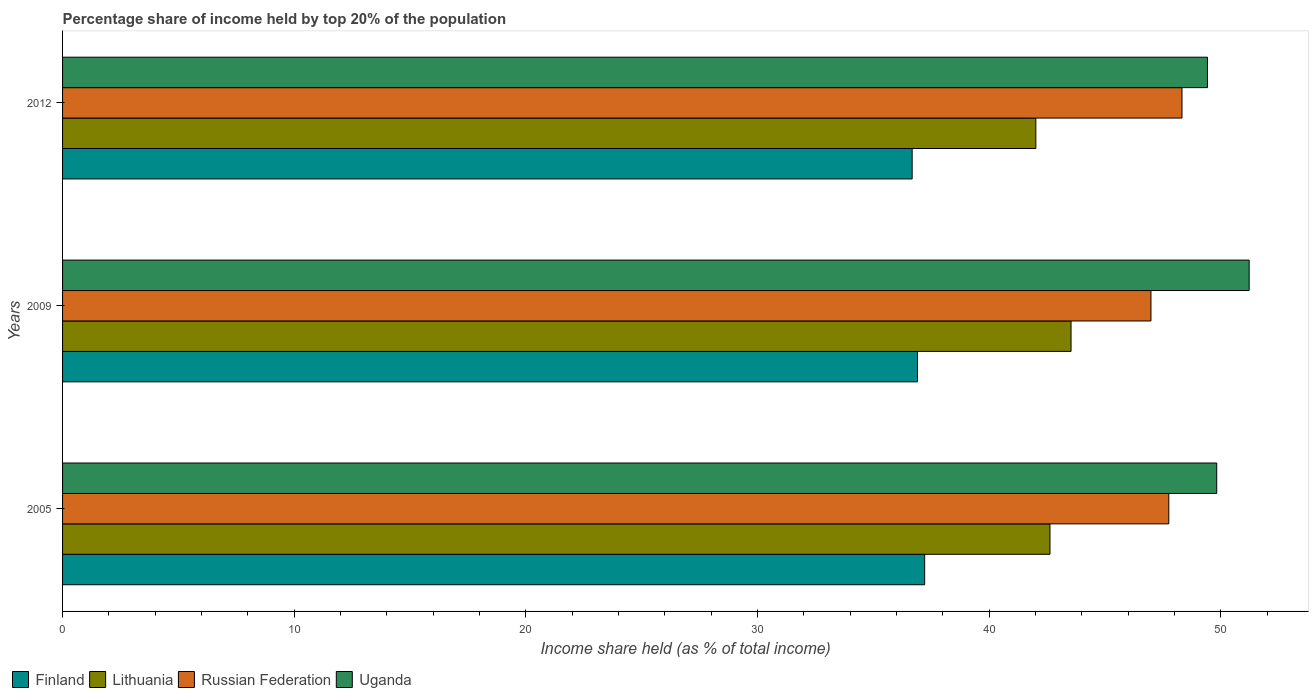Are the number of bars per tick equal to the number of legend labels?
Make the answer very short. Yes. Are the number of bars on each tick of the Y-axis equal?
Your answer should be very brief. Yes. How many bars are there on the 2nd tick from the top?
Offer a terse response. 4. How many bars are there on the 2nd tick from the bottom?
Your answer should be compact. 4. What is the label of the 2nd group of bars from the top?
Make the answer very short. 2009. In how many cases, is the number of bars for a given year not equal to the number of legend labels?
Provide a short and direct response. 0. What is the percentage share of income held by top 20% of the population in Uganda in 2009?
Provide a short and direct response. 51.23. Across all years, what is the maximum percentage share of income held by top 20% of the population in Russian Federation?
Make the answer very short. 48.33. Across all years, what is the minimum percentage share of income held by top 20% of the population in Lithuania?
Make the answer very short. 42.02. In which year was the percentage share of income held by top 20% of the population in Uganda minimum?
Keep it short and to the point. 2012. What is the total percentage share of income held by top 20% of the population in Russian Federation in the graph?
Offer a terse response. 143.08. What is the difference between the percentage share of income held by top 20% of the population in Lithuania in 2009 and that in 2012?
Make the answer very short. 1.52. What is the difference between the percentage share of income held by top 20% of the population in Uganda in 2005 and the percentage share of income held by top 20% of the population in Finland in 2012?
Your answer should be very brief. 13.15. What is the average percentage share of income held by top 20% of the population in Finland per year?
Offer a very short reply. 36.94. In the year 2012, what is the difference between the percentage share of income held by top 20% of the population in Uganda and percentage share of income held by top 20% of the population in Finland?
Provide a succinct answer. 12.75. In how many years, is the percentage share of income held by top 20% of the population in Uganda greater than 4 %?
Your answer should be compact. 3. What is the ratio of the percentage share of income held by top 20% of the population in Finland in 2005 to that in 2012?
Ensure brevity in your answer.  1.01. Is the percentage share of income held by top 20% of the population in Lithuania in 2005 less than that in 2012?
Your answer should be very brief. No. What is the difference between the highest and the second highest percentage share of income held by top 20% of the population in Russian Federation?
Offer a terse response. 0.57. What is the difference between the highest and the lowest percentage share of income held by top 20% of the population in Russian Federation?
Ensure brevity in your answer.  1.34. In how many years, is the percentage share of income held by top 20% of the population in Uganda greater than the average percentage share of income held by top 20% of the population in Uganda taken over all years?
Provide a succinct answer. 1. Is the sum of the percentage share of income held by top 20% of the population in Uganda in 2005 and 2009 greater than the maximum percentage share of income held by top 20% of the population in Lithuania across all years?
Your answer should be compact. Yes. Is it the case that in every year, the sum of the percentage share of income held by top 20% of the population in Finland and percentage share of income held by top 20% of the population in Lithuania is greater than the sum of percentage share of income held by top 20% of the population in Uganda and percentage share of income held by top 20% of the population in Russian Federation?
Your answer should be very brief. Yes. What does the 3rd bar from the top in 2009 represents?
Provide a short and direct response. Lithuania. What does the 1st bar from the bottom in 2012 represents?
Offer a very short reply. Finland. How many bars are there?
Provide a succinct answer. 12. Are all the bars in the graph horizontal?
Give a very brief answer. Yes. How many years are there in the graph?
Keep it short and to the point. 3. What is the difference between two consecutive major ticks on the X-axis?
Your answer should be compact. 10. Does the graph contain grids?
Provide a short and direct response. No. Where does the legend appear in the graph?
Offer a very short reply. Bottom left. How are the legend labels stacked?
Provide a succinct answer. Horizontal. What is the title of the graph?
Your answer should be compact. Percentage share of income held by top 20% of the population. Does "Kiribati" appear as one of the legend labels in the graph?
Ensure brevity in your answer.  No. What is the label or title of the X-axis?
Ensure brevity in your answer.  Income share held (as % of total income). What is the label or title of the Y-axis?
Offer a terse response. Years. What is the Income share held (as % of total income) in Finland in 2005?
Offer a very short reply. 37.22. What is the Income share held (as % of total income) of Lithuania in 2005?
Offer a terse response. 42.63. What is the Income share held (as % of total income) in Russian Federation in 2005?
Ensure brevity in your answer.  47.76. What is the Income share held (as % of total income) of Uganda in 2005?
Your answer should be very brief. 49.83. What is the Income share held (as % of total income) in Finland in 2009?
Ensure brevity in your answer.  36.91. What is the Income share held (as % of total income) in Lithuania in 2009?
Provide a short and direct response. 43.54. What is the Income share held (as % of total income) in Russian Federation in 2009?
Your answer should be compact. 46.99. What is the Income share held (as % of total income) in Uganda in 2009?
Keep it short and to the point. 51.23. What is the Income share held (as % of total income) in Finland in 2012?
Provide a short and direct response. 36.68. What is the Income share held (as % of total income) of Lithuania in 2012?
Ensure brevity in your answer.  42.02. What is the Income share held (as % of total income) in Russian Federation in 2012?
Provide a short and direct response. 48.33. What is the Income share held (as % of total income) in Uganda in 2012?
Your answer should be very brief. 49.43. Across all years, what is the maximum Income share held (as % of total income) in Finland?
Offer a very short reply. 37.22. Across all years, what is the maximum Income share held (as % of total income) of Lithuania?
Offer a very short reply. 43.54. Across all years, what is the maximum Income share held (as % of total income) in Russian Federation?
Your answer should be compact. 48.33. Across all years, what is the maximum Income share held (as % of total income) in Uganda?
Your answer should be compact. 51.23. Across all years, what is the minimum Income share held (as % of total income) of Finland?
Your answer should be very brief. 36.68. Across all years, what is the minimum Income share held (as % of total income) of Lithuania?
Ensure brevity in your answer.  42.02. Across all years, what is the minimum Income share held (as % of total income) in Russian Federation?
Your answer should be very brief. 46.99. Across all years, what is the minimum Income share held (as % of total income) in Uganda?
Provide a short and direct response. 49.43. What is the total Income share held (as % of total income) of Finland in the graph?
Your response must be concise. 110.81. What is the total Income share held (as % of total income) in Lithuania in the graph?
Offer a terse response. 128.19. What is the total Income share held (as % of total income) in Russian Federation in the graph?
Provide a succinct answer. 143.08. What is the total Income share held (as % of total income) of Uganda in the graph?
Give a very brief answer. 150.49. What is the difference between the Income share held (as % of total income) in Finland in 2005 and that in 2009?
Provide a succinct answer. 0.31. What is the difference between the Income share held (as % of total income) of Lithuania in 2005 and that in 2009?
Offer a terse response. -0.91. What is the difference between the Income share held (as % of total income) of Russian Federation in 2005 and that in 2009?
Keep it short and to the point. 0.77. What is the difference between the Income share held (as % of total income) in Finland in 2005 and that in 2012?
Give a very brief answer. 0.54. What is the difference between the Income share held (as % of total income) in Lithuania in 2005 and that in 2012?
Your response must be concise. 0.61. What is the difference between the Income share held (as % of total income) of Russian Federation in 2005 and that in 2012?
Make the answer very short. -0.57. What is the difference between the Income share held (as % of total income) of Finland in 2009 and that in 2012?
Your answer should be compact. 0.23. What is the difference between the Income share held (as % of total income) in Lithuania in 2009 and that in 2012?
Your response must be concise. 1.52. What is the difference between the Income share held (as % of total income) of Russian Federation in 2009 and that in 2012?
Make the answer very short. -1.34. What is the difference between the Income share held (as % of total income) in Finland in 2005 and the Income share held (as % of total income) in Lithuania in 2009?
Make the answer very short. -6.32. What is the difference between the Income share held (as % of total income) of Finland in 2005 and the Income share held (as % of total income) of Russian Federation in 2009?
Keep it short and to the point. -9.77. What is the difference between the Income share held (as % of total income) in Finland in 2005 and the Income share held (as % of total income) in Uganda in 2009?
Provide a succinct answer. -14.01. What is the difference between the Income share held (as % of total income) in Lithuania in 2005 and the Income share held (as % of total income) in Russian Federation in 2009?
Keep it short and to the point. -4.36. What is the difference between the Income share held (as % of total income) of Russian Federation in 2005 and the Income share held (as % of total income) of Uganda in 2009?
Your answer should be compact. -3.47. What is the difference between the Income share held (as % of total income) in Finland in 2005 and the Income share held (as % of total income) in Lithuania in 2012?
Keep it short and to the point. -4.8. What is the difference between the Income share held (as % of total income) of Finland in 2005 and the Income share held (as % of total income) of Russian Federation in 2012?
Offer a terse response. -11.11. What is the difference between the Income share held (as % of total income) in Finland in 2005 and the Income share held (as % of total income) in Uganda in 2012?
Provide a short and direct response. -12.21. What is the difference between the Income share held (as % of total income) in Russian Federation in 2005 and the Income share held (as % of total income) in Uganda in 2012?
Your answer should be compact. -1.67. What is the difference between the Income share held (as % of total income) in Finland in 2009 and the Income share held (as % of total income) in Lithuania in 2012?
Your response must be concise. -5.11. What is the difference between the Income share held (as % of total income) in Finland in 2009 and the Income share held (as % of total income) in Russian Federation in 2012?
Your answer should be compact. -11.42. What is the difference between the Income share held (as % of total income) of Finland in 2009 and the Income share held (as % of total income) of Uganda in 2012?
Provide a succinct answer. -12.52. What is the difference between the Income share held (as % of total income) of Lithuania in 2009 and the Income share held (as % of total income) of Russian Federation in 2012?
Provide a short and direct response. -4.79. What is the difference between the Income share held (as % of total income) in Lithuania in 2009 and the Income share held (as % of total income) in Uganda in 2012?
Give a very brief answer. -5.89. What is the difference between the Income share held (as % of total income) of Russian Federation in 2009 and the Income share held (as % of total income) of Uganda in 2012?
Provide a succinct answer. -2.44. What is the average Income share held (as % of total income) in Finland per year?
Offer a terse response. 36.94. What is the average Income share held (as % of total income) of Lithuania per year?
Offer a terse response. 42.73. What is the average Income share held (as % of total income) of Russian Federation per year?
Your answer should be compact. 47.69. What is the average Income share held (as % of total income) in Uganda per year?
Your answer should be compact. 50.16. In the year 2005, what is the difference between the Income share held (as % of total income) in Finland and Income share held (as % of total income) in Lithuania?
Your answer should be very brief. -5.41. In the year 2005, what is the difference between the Income share held (as % of total income) of Finland and Income share held (as % of total income) of Russian Federation?
Keep it short and to the point. -10.54. In the year 2005, what is the difference between the Income share held (as % of total income) of Finland and Income share held (as % of total income) of Uganda?
Your answer should be compact. -12.61. In the year 2005, what is the difference between the Income share held (as % of total income) in Lithuania and Income share held (as % of total income) in Russian Federation?
Keep it short and to the point. -5.13. In the year 2005, what is the difference between the Income share held (as % of total income) in Russian Federation and Income share held (as % of total income) in Uganda?
Give a very brief answer. -2.07. In the year 2009, what is the difference between the Income share held (as % of total income) of Finland and Income share held (as % of total income) of Lithuania?
Make the answer very short. -6.63. In the year 2009, what is the difference between the Income share held (as % of total income) of Finland and Income share held (as % of total income) of Russian Federation?
Offer a very short reply. -10.08. In the year 2009, what is the difference between the Income share held (as % of total income) in Finland and Income share held (as % of total income) in Uganda?
Give a very brief answer. -14.32. In the year 2009, what is the difference between the Income share held (as % of total income) of Lithuania and Income share held (as % of total income) of Russian Federation?
Make the answer very short. -3.45. In the year 2009, what is the difference between the Income share held (as % of total income) of Lithuania and Income share held (as % of total income) of Uganda?
Your answer should be compact. -7.69. In the year 2009, what is the difference between the Income share held (as % of total income) in Russian Federation and Income share held (as % of total income) in Uganda?
Provide a succinct answer. -4.24. In the year 2012, what is the difference between the Income share held (as % of total income) in Finland and Income share held (as % of total income) in Lithuania?
Keep it short and to the point. -5.34. In the year 2012, what is the difference between the Income share held (as % of total income) in Finland and Income share held (as % of total income) in Russian Federation?
Provide a short and direct response. -11.65. In the year 2012, what is the difference between the Income share held (as % of total income) in Finland and Income share held (as % of total income) in Uganda?
Your answer should be compact. -12.75. In the year 2012, what is the difference between the Income share held (as % of total income) of Lithuania and Income share held (as % of total income) of Russian Federation?
Offer a terse response. -6.31. In the year 2012, what is the difference between the Income share held (as % of total income) of Lithuania and Income share held (as % of total income) of Uganda?
Provide a succinct answer. -7.41. In the year 2012, what is the difference between the Income share held (as % of total income) of Russian Federation and Income share held (as % of total income) of Uganda?
Ensure brevity in your answer.  -1.1. What is the ratio of the Income share held (as % of total income) in Finland in 2005 to that in 2009?
Provide a succinct answer. 1.01. What is the ratio of the Income share held (as % of total income) in Lithuania in 2005 to that in 2009?
Offer a very short reply. 0.98. What is the ratio of the Income share held (as % of total income) in Russian Federation in 2005 to that in 2009?
Offer a terse response. 1.02. What is the ratio of the Income share held (as % of total income) in Uganda in 2005 to that in 2009?
Ensure brevity in your answer.  0.97. What is the ratio of the Income share held (as % of total income) in Finland in 2005 to that in 2012?
Make the answer very short. 1.01. What is the ratio of the Income share held (as % of total income) of Lithuania in 2005 to that in 2012?
Your response must be concise. 1.01. What is the ratio of the Income share held (as % of total income) in Finland in 2009 to that in 2012?
Give a very brief answer. 1.01. What is the ratio of the Income share held (as % of total income) of Lithuania in 2009 to that in 2012?
Your answer should be very brief. 1.04. What is the ratio of the Income share held (as % of total income) in Russian Federation in 2009 to that in 2012?
Ensure brevity in your answer.  0.97. What is the ratio of the Income share held (as % of total income) in Uganda in 2009 to that in 2012?
Your answer should be very brief. 1.04. What is the difference between the highest and the second highest Income share held (as % of total income) in Finland?
Provide a short and direct response. 0.31. What is the difference between the highest and the second highest Income share held (as % of total income) of Lithuania?
Offer a terse response. 0.91. What is the difference between the highest and the second highest Income share held (as % of total income) of Russian Federation?
Your response must be concise. 0.57. What is the difference between the highest and the second highest Income share held (as % of total income) in Uganda?
Your response must be concise. 1.4. What is the difference between the highest and the lowest Income share held (as % of total income) in Finland?
Provide a succinct answer. 0.54. What is the difference between the highest and the lowest Income share held (as % of total income) in Lithuania?
Provide a succinct answer. 1.52. What is the difference between the highest and the lowest Income share held (as % of total income) in Russian Federation?
Offer a terse response. 1.34. What is the difference between the highest and the lowest Income share held (as % of total income) of Uganda?
Your answer should be compact. 1.8. 